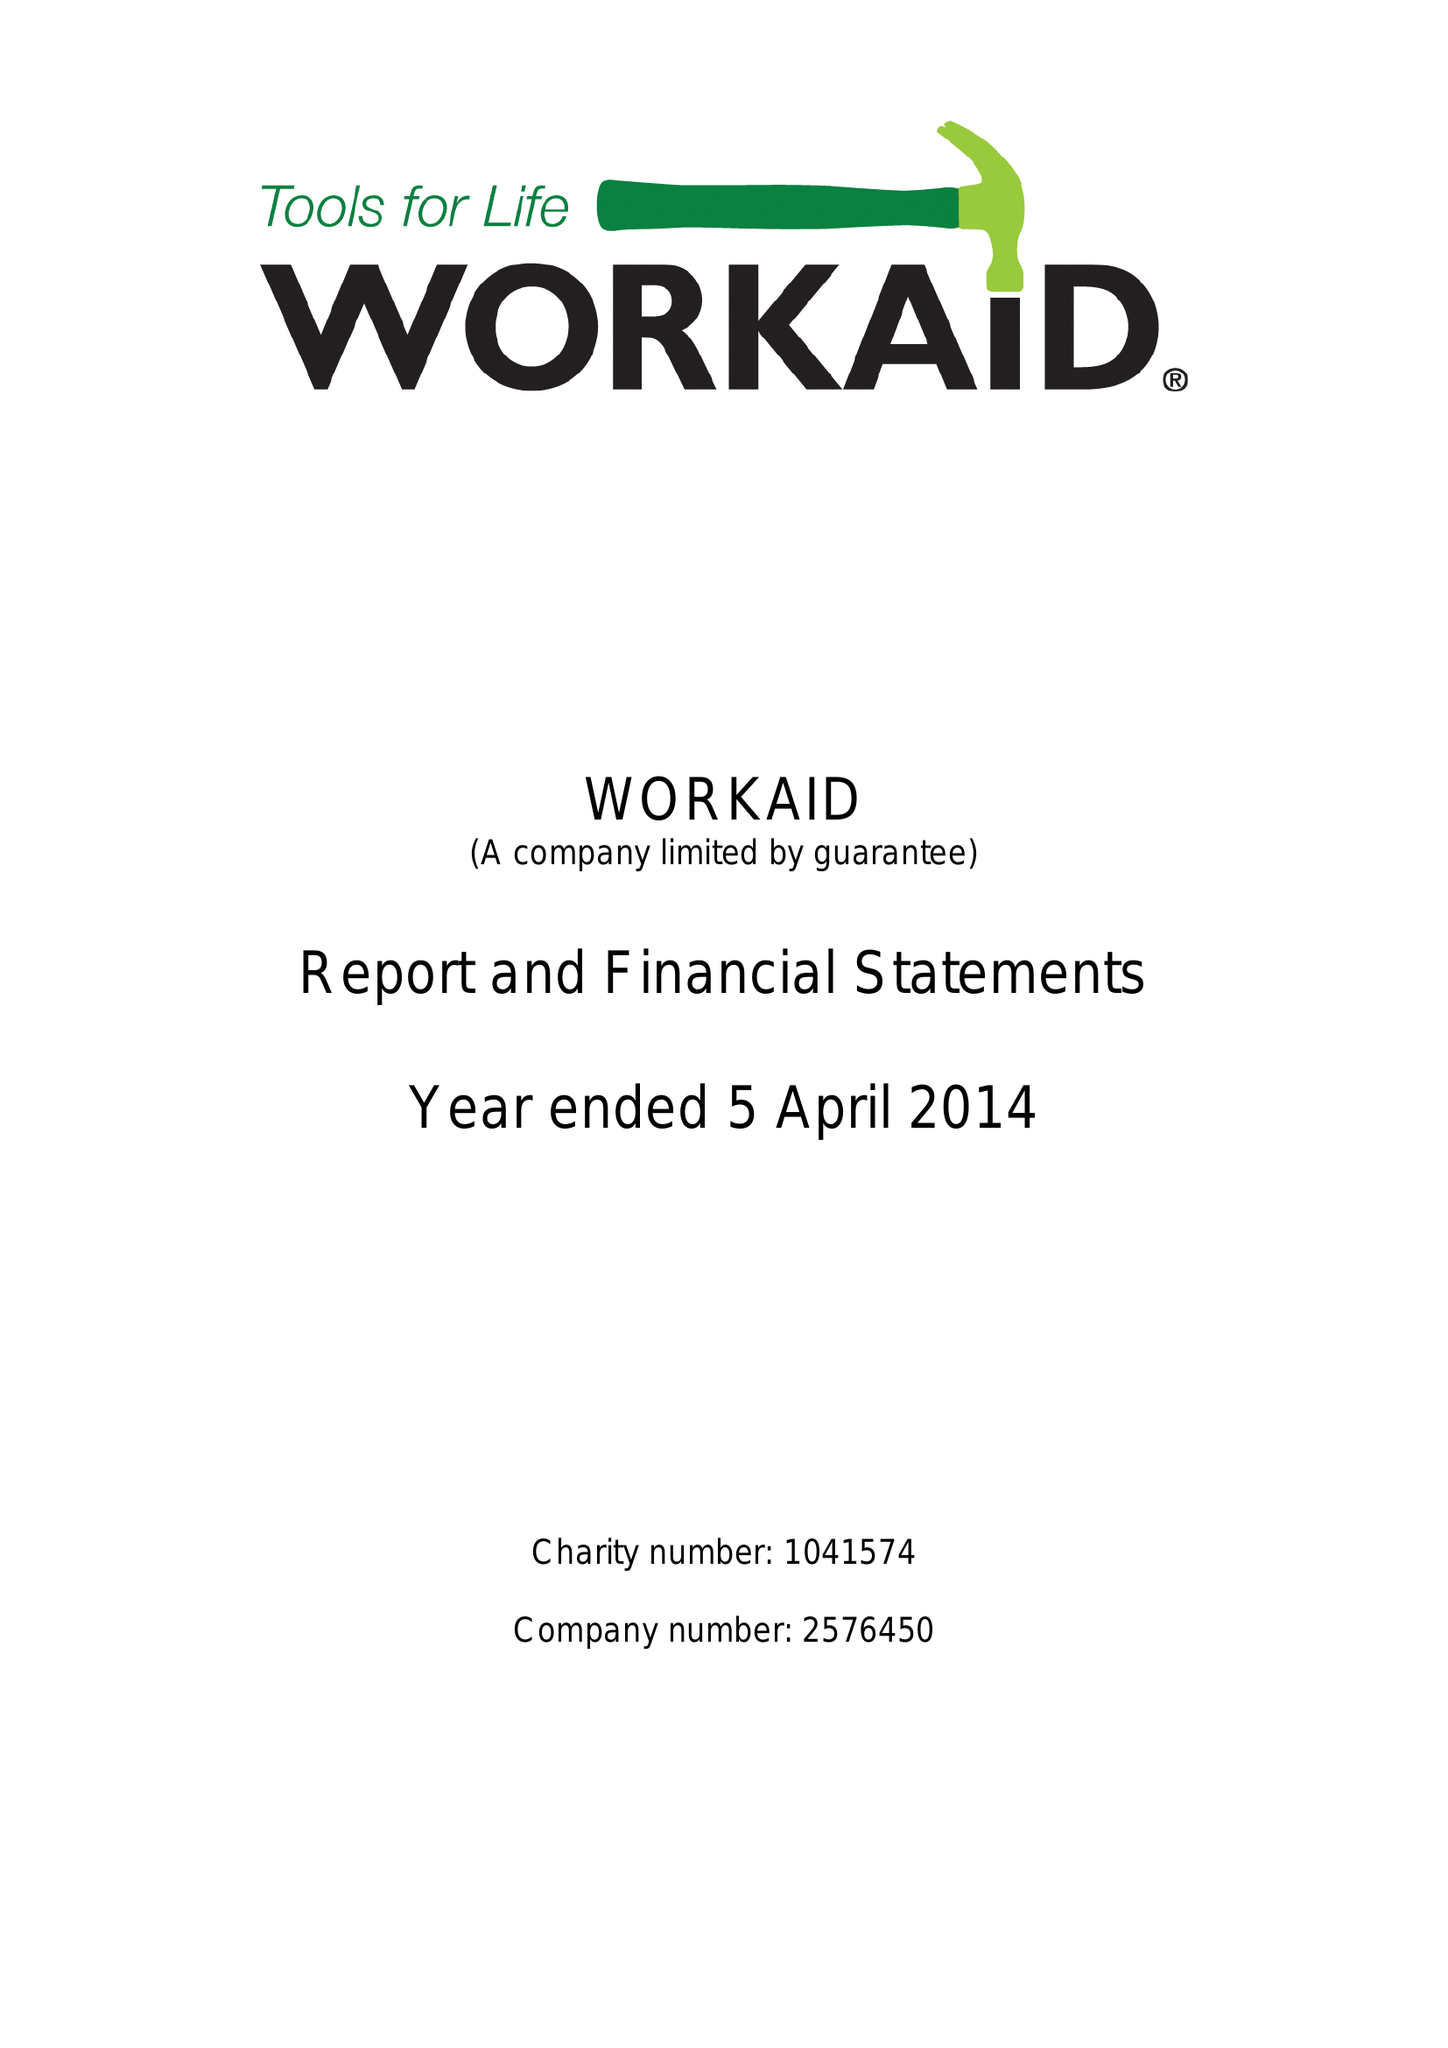What is the value for the income_annually_in_british_pounds?
Answer the question using a single word or phrase. 396622.00 